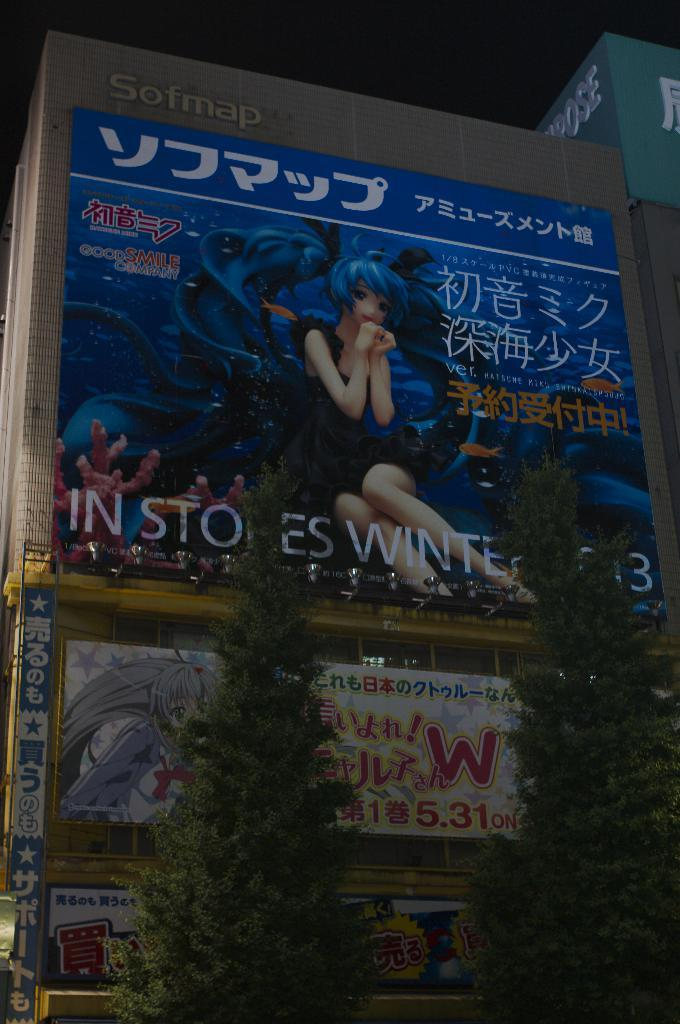<image>
Relay a brief, clear account of the picture shown. An electronic billboard shows a product which promises to be in stores by winter. 